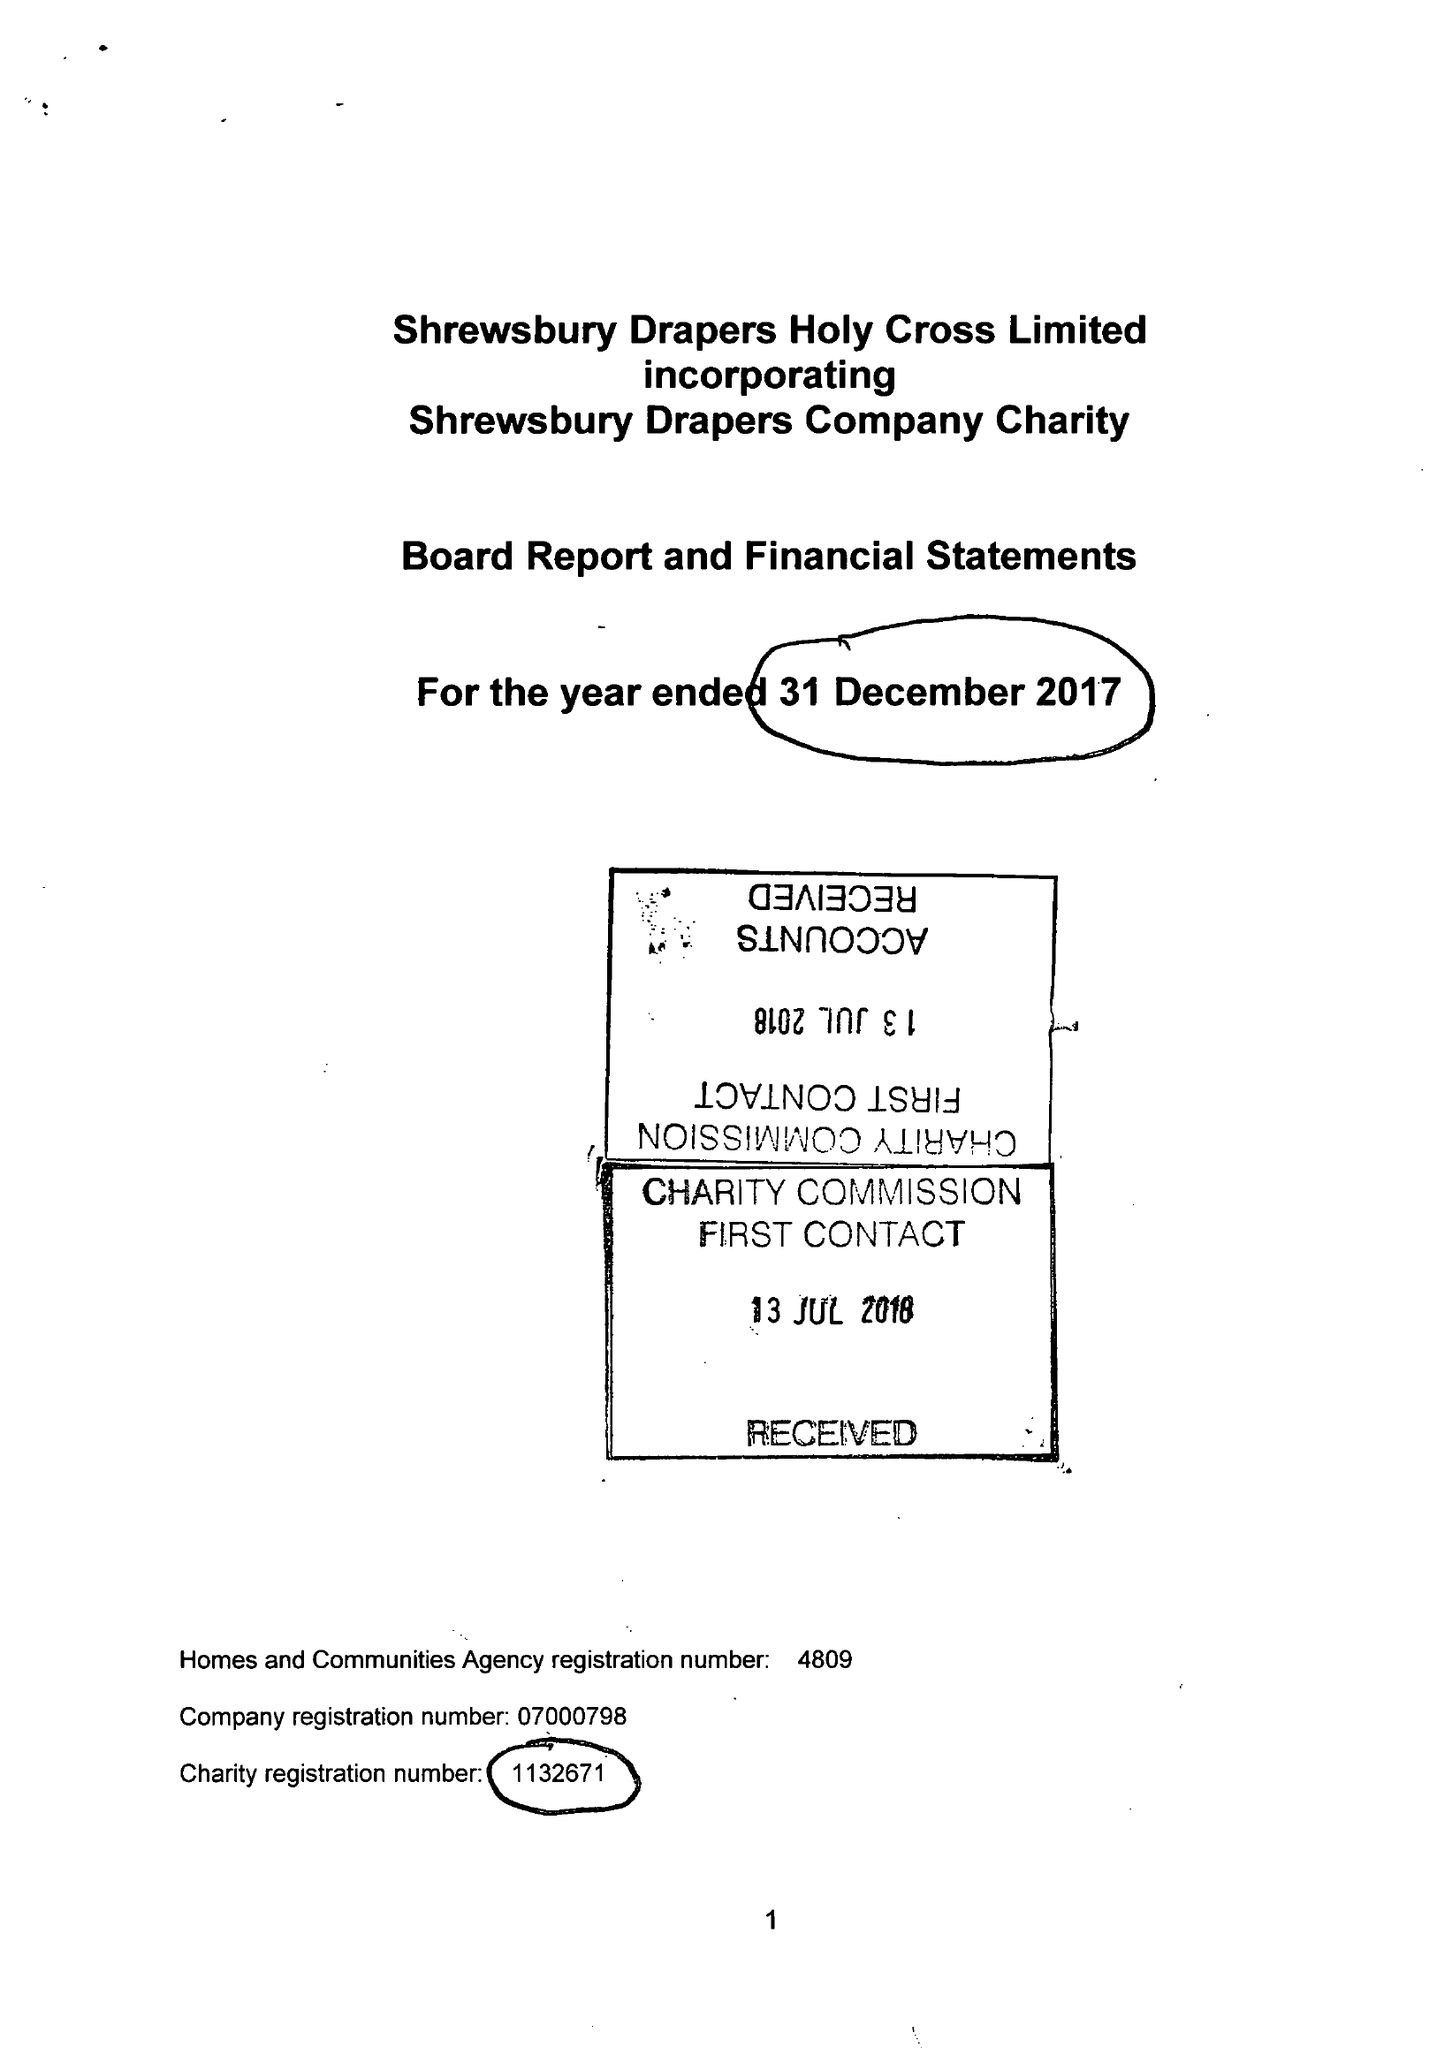What is the value for the report_date?
Answer the question using a single word or phrase. 2017-12-31 